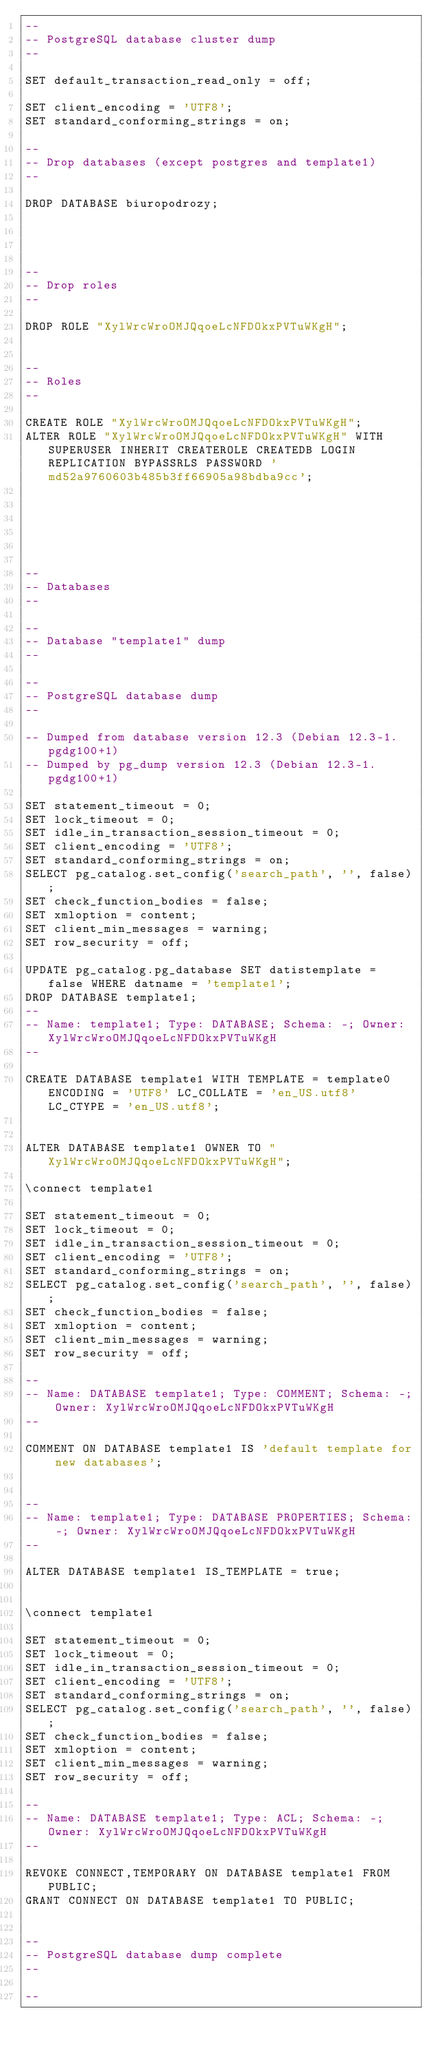<code> <loc_0><loc_0><loc_500><loc_500><_SQL_>--
-- PostgreSQL database cluster dump
--

SET default_transaction_read_only = off;

SET client_encoding = 'UTF8';
SET standard_conforming_strings = on;

--
-- Drop databases (except postgres and template1)
--

DROP DATABASE biuropodrozy;




--
-- Drop roles
--

DROP ROLE "XylWrcWroOMJQqoeLcNFDOkxPVTuWKgH";


--
-- Roles
--

CREATE ROLE "XylWrcWroOMJQqoeLcNFDOkxPVTuWKgH";
ALTER ROLE "XylWrcWroOMJQqoeLcNFDOkxPVTuWKgH" WITH SUPERUSER INHERIT CREATEROLE CREATEDB LOGIN REPLICATION BYPASSRLS PASSWORD 'md52a9760603b485b3ff66905a98bdba9cc';






--
-- Databases
--

--
-- Database "template1" dump
--

--
-- PostgreSQL database dump
--

-- Dumped from database version 12.3 (Debian 12.3-1.pgdg100+1)
-- Dumped by pg_dump version 12.3 (Debian 12.3-1.pgdg100+1)

SET statement_timeout = 0;
SET lock_timeout = 0;
SET idle_in_transaction_session_timeout = 0;
SET client_encoding = 'UTF8';
SET standard_conforming_strings = on;
SELECT pg_catalog.set_config('search_path', '', false);
SET check_function_bodies = false;
SET xmloption = content;
SET client_min_messages = warning;
SET row_security = off;

UPDATE pg_catalog.pg_database SET datistemplate = false WHERE datname = 'template1';
DROP DATABASE template1;
--
-- Name: template1; Type: DATABASE; Schema: -; Owner: XylWrcWroOMJQqoeLcNFDOkxPVTuWKgH
--

CREATE DATABASE template1 WITH TEMPLATE = template0 ENCODING = 'UTF8' LC_COLLATE = 'en_US.utf8' LC_CTYPE = 'en_US.utf8';


ALTER DATABASE template1 OWNER TO "XylWrcWroOMJQqoeLcNFDOkxPVTuWKgH";

\connect template1

SET statement_timeout = 0;
SET lock_timeout = 0;
SET idle_in_transaction_session_timeout = 0;
SET client_encoding = 'UTF8';
SET standard_conforming_strings = on;
SELECT pg_catalog.set_config('search_path', '', false);
SET check_function_bodies = false;
SET xmloption = content;
SET client_min_messages = warning;
SET row_security = off;

--
-- Name: DATABASE template1; Type: COMMENT; Schema: -; Owner: XylWrcWroOMJQqoeLcNFDOkxPVTuWKgH
--

COMMENT ON DATABASE template1 IS 'default template for new databases';


--
-- Name: template1; Type: DATABASE PROPERTIES; Schema: -; Owner: XylWrcWroOMJQqoeLcNFDOkxPVTuWKgH
--

ALTER DATABASE template1 IS_TEMPLATE = true;


\connect template1

SET statement_timeout = 0;
SET lock_timeout = 0;
SET idle_in_transaction_session_timeout = 0;
SET client_encoding = 'UTF8';
SET standard_conforming_strings = on;
SELECT pg_catalog.set_config('search_path', '', false);
SET check_function_bodies = false;
SET xmloption = content;
SET client_min_messages = warning;
SET row_security = off;

--
-- Name: DATABASE template1; Type: ACL; Schema: -; Owner: XylWrcWroOMJQqoeLcNFDOkxPVTuWKgH
--

REVOKE CONNECT,TEMPORARY ON DATABASE template1 FROM PUBLIC;
GRANT CONNECT ON DATABASE template1 TO PUBLIC;


--
-- PostgreSQL database dump complete
--

--</code> 